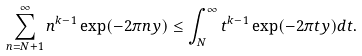<formula> <loc_0><loc_0><loc_500><loc_500>\sum _ { n = N + 1 } ^ { \infty } n ^ { k - 1 } \exp ( - 2 \pi n y ) \leq \int _ { N } ^ { \infty } t ^ { k - 1 } \exp ( - 2 \pi t y ) d t .</formula> 